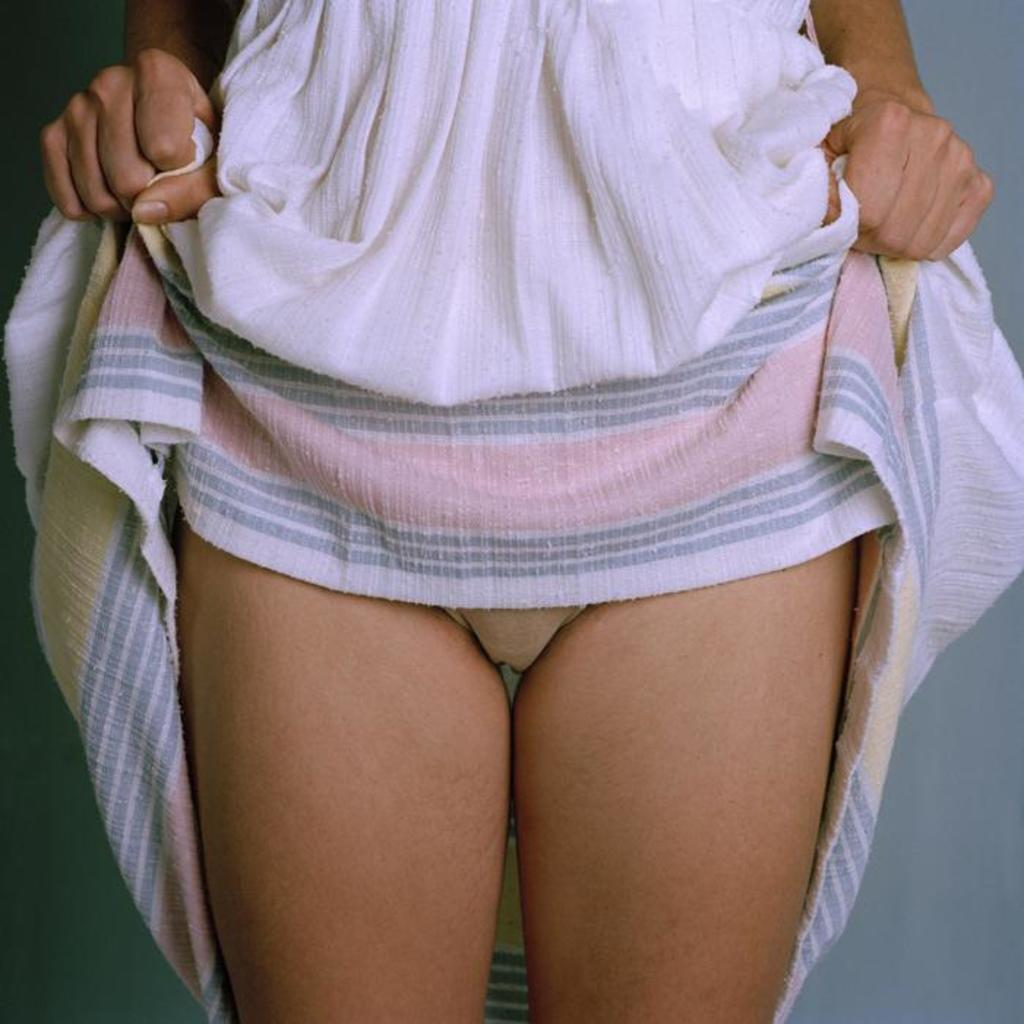What is the main subject of the image? The main subject of the image is a woman. What is the woman doing in the image? The woman is standing and raising her dress upwards. What type of fang can be seen in the woman's mouth in the image? There is no fang visible in the woman's mouth in the image. What type of truck is parked behind the woman in the image? There is no truck present in the image; it only features a woman standing and raising her dress upwards. 